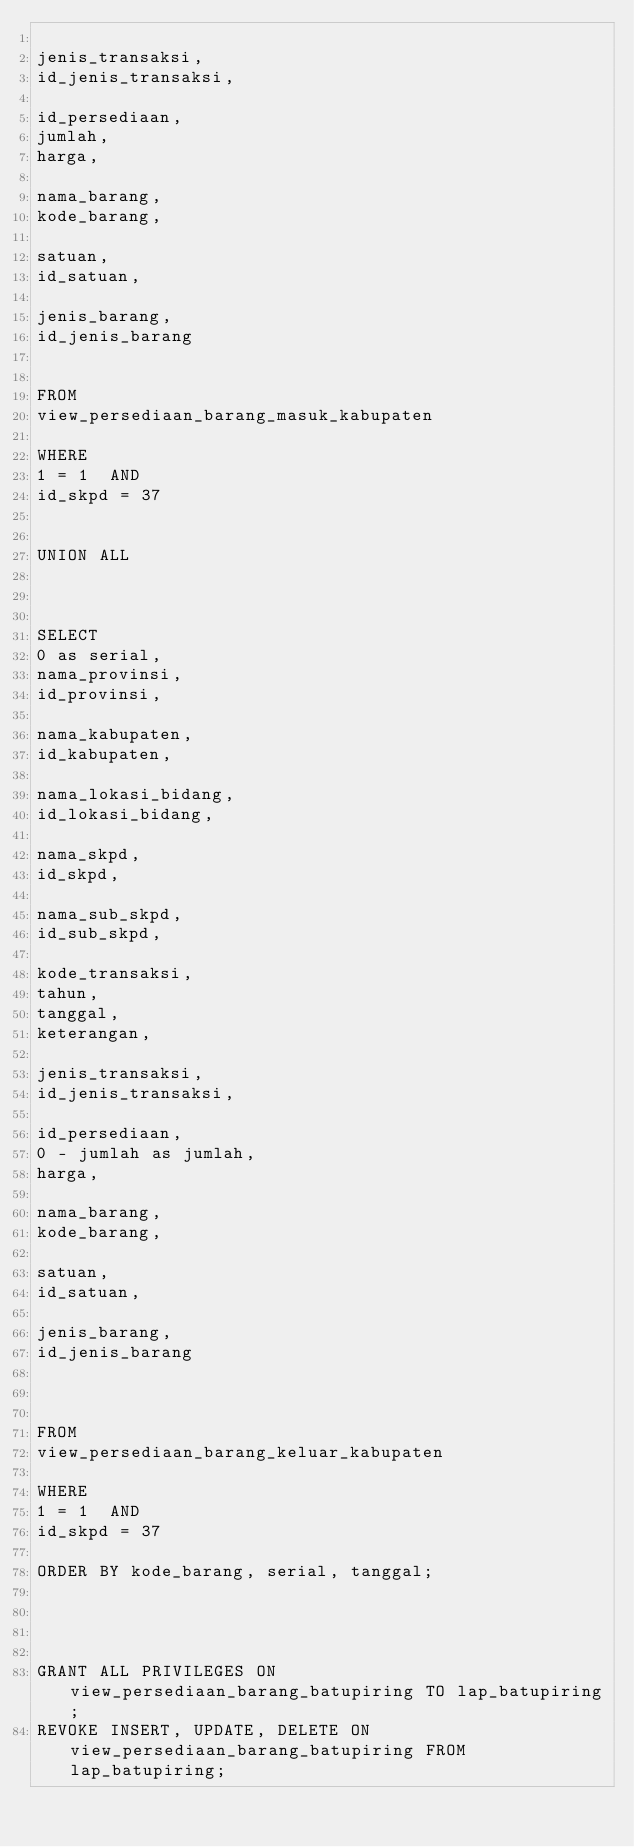<code> <loc_0><loc_0><loc_500><loc_500><_SQL_>
jenis_transaksi,
id_jenis_transaksi,

id_persediaan,
jumlah,
harga,

nama_barang,
kode_barang,

satuan,
id_satuan,

jenis_barang,
id_jenis_barang


FROM
view_persediaan_barang_masuk_kabupaten

WHERE
1 = 1  AND
id_skpd = 37


UNION ALL



SELECT
0 as serial,
nama_provinsi,
id_provinsi,

nama_kabupaten,
id_kabupaten,

nama_lokasi_bidang,
id_lokasi_bidang,

nama_skpd,
id_skpd,

nama_sub_skpd,
id_sub_skpd,

kode_transaksi,
tahun,
tanggal,
keterangan,

jenis_transaksi,
id_jenis_transaksi,

id_persediaan,
0 - jumlah as jumlah,
harga,

nama_barang,
kode_barang,

satuan,
id_satuan,

jenis_barang,
id_jenis_barang



FROM
view_persediaan_barang_keluar_kabupaten

WHERE
1 = 1  AND
id_skpd = 37

ORDER BY kode_barang, serial, tanggal;




GRANT ALL PRIVILEGES ON view_persediaan_barang_batupiring TO lap_batupiring;
REVOKE INSERT, UPDATE, DELETE ON view_persediaan_barang_batupiring FROM lap_batupiring;
</code> 